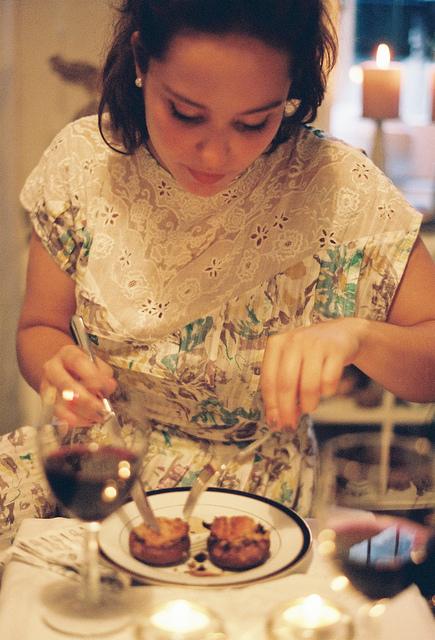Is this meat cooked the way I like it?
Quick response, please. Yes. What is the woman doing with the knife and fork?
Write a very short answer. Eating. Is this woman using the right utensils to cut this food?
Quick response, please. Yes. 